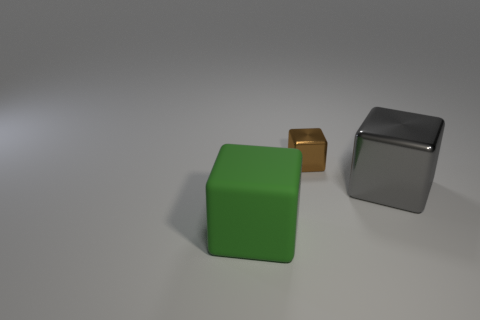Are there any other things that are made of the same material as the large green cube?
Offer a very short reply. No. How many objects are either objects left of the big gray metal block or large objects that are behind the large green object?
Your response must be concise. 3. Are there the same number of big metallic objects in front of the big gray cube and large rubber things behind the large rubber cube?
Your answer should be compact. Yes. The cube that is right of the brown thing is what color?
Keep it short and to the point. Gray. Is the number of metal objects less than the number of objects?
Give a very brief answer. Yes. How many blue objects have the same size as the green thing?
Give a very brief answer. 0. Does the small brown thing have the same material as the large green object?
Ensure brevity in your answer.  No. What number of big rubber objects have the same shape as the small thing?
Give a very brief answer. 1. There is a big gray thing that is made of the same material as the small object; what shape is it?
Give a very brief answer. Cube. There is a shiny object behind the big thing on the right side of the green thing; what color is it?
Provide a short and direct response. Brown. 